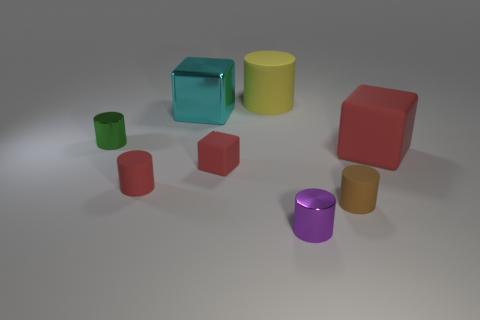What material is the big object that is right of the tiny brown object that is in front of the tiny rubber cylinder that is left of the big cyan metal thing?
Your answer should be compact. Rubber. How many matte objects are either big green cylinders or large cyan objects?
Give a very brief answer. 0. What number of red objects are big matte objects or small metal cylinders?
Keep it short and to the point. 1. Do the large cube right of the small brown matte cylinder and the small block have the same color?
Your answer should be very brief. Yes. Do the purple cylinder and the cyan object have the same material?
Provide a succinct answer. Yes. Are there an equal number of cyan metallic things on the right side of the purple shiny thing and shiny cylinders that are to the right of the tiny green thing?
Your response must be concise. No. There is a red thing that is the same shape as the brown rubber thing; what material is it?
Make the answer very short. Rubber. What shape is the green thing left of the small metallic cylinder that is on the right side of the green metallic object behind the brown object?
Give a very brief answer. Cylinder. Is the number of large blocks on the left side of the tiny purple cylinder greater than the number of small green balls?
Your answer should be compact. Yes. Is the shape of the metal thing right of the cyan shiny thing the same as  the big cyan shiny object?
Your response must be concise. No. 